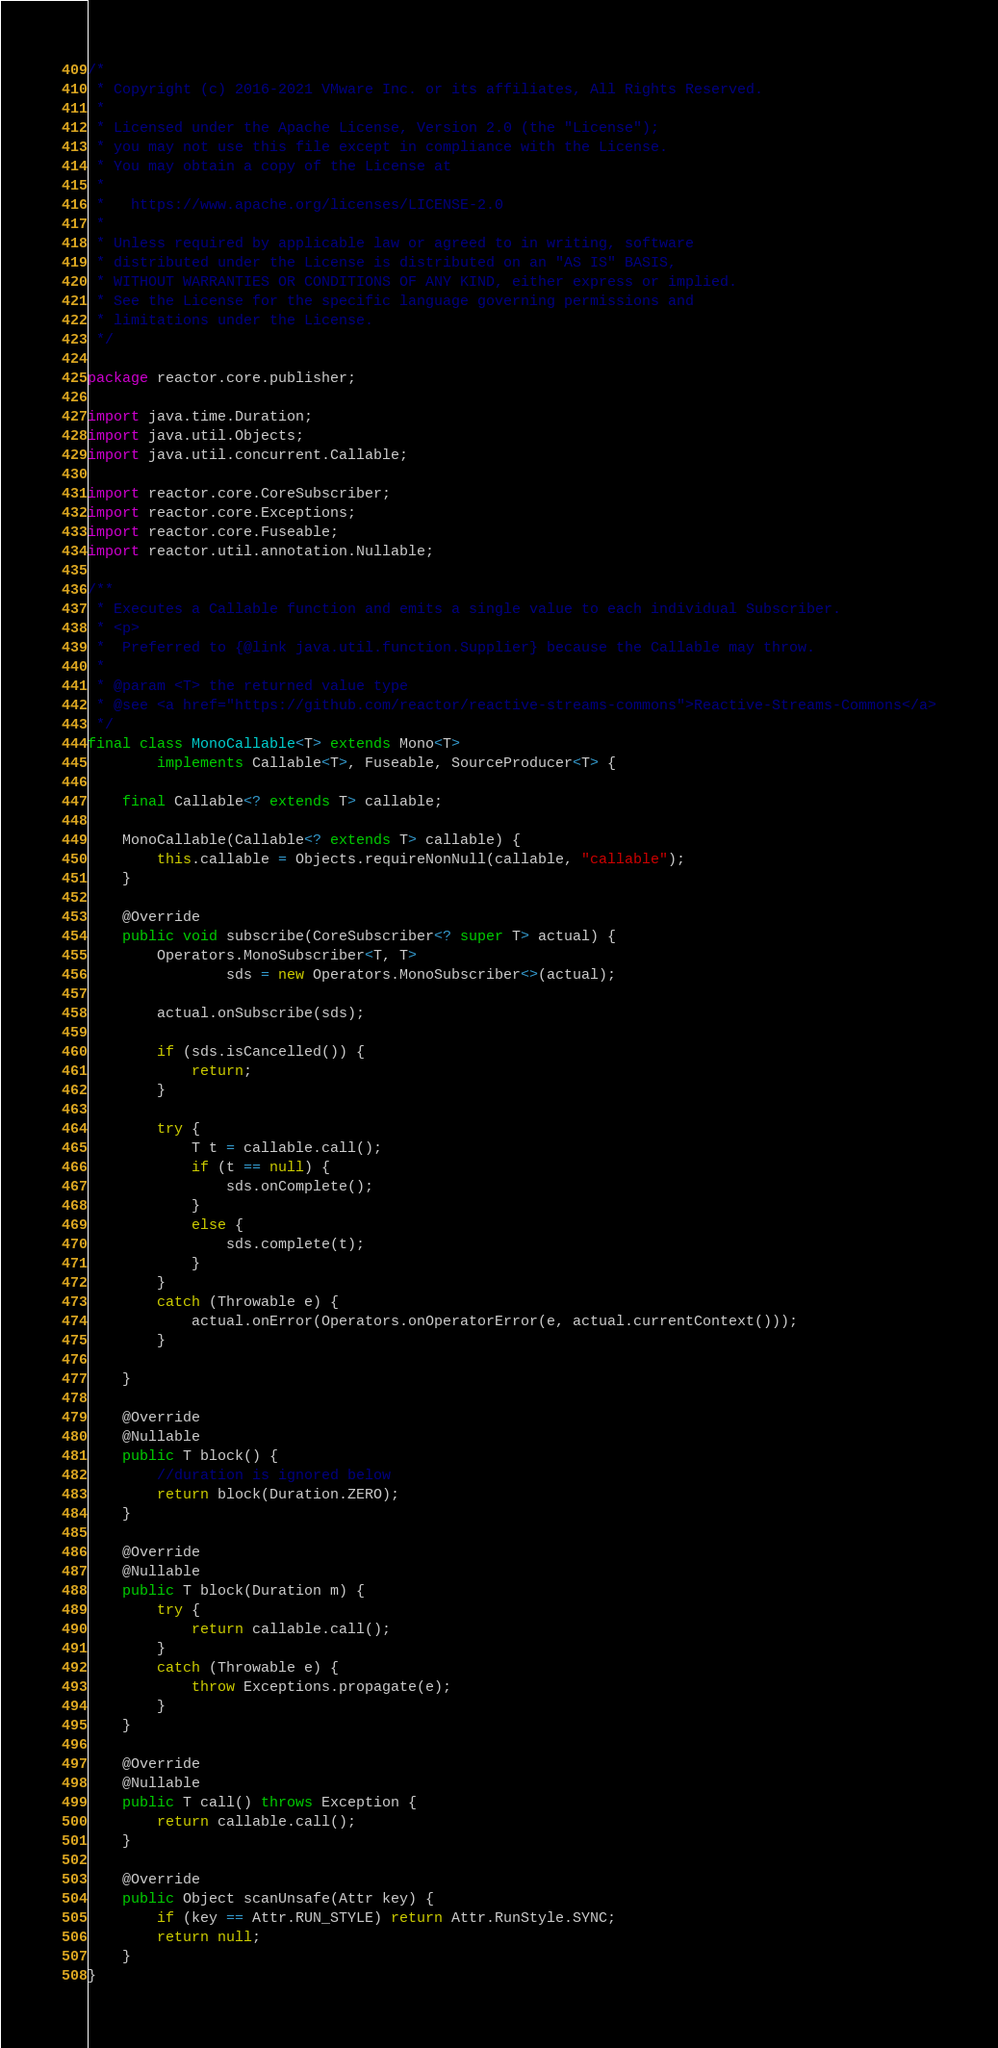Convert code to text. <code><loc_0><loc_0><loc_500><loc_500><_Java_>/*
 * Copyright (c) 2016-2021 VMware Inc. or its affiliates, All Rights Reserved.
 *
 * Licensed under the Apache License, Version 2.0 (the "License");
 * you may not use this file except in compliance with the License.
 * You may obtain a copy of the License at
 *
 *   https://www.apache.org/licenses/LICENSE-2.0
 *
 * Unless required by applicable law or agreed to in writing, software
 * distributed under the License is distributed on an "AS IS" BASIS,
 * WITHOUT WARRANTIES OR CONDITIONS OF ANY KIND, either express or implied.
 * See the License for the specific language governing permissions and
 * limitations under the License.
 */

package reactor.core.publisher;

import java.time.Duration;
import java.util.Objects;
import java.util.concurrent.Callable;

import reactor.core.CoreSubscriber;
import reactor.core.Exceptions;
import reactor.core.Fuseable;
import reactor.util.annotation.Nullable;

/**
 * Executes a Callable function and emits a single value to each individual Subscriber.
 * <p>
 *  Preferred to {@link java.util.function.Supplier} because the Callable may throw.
 *
 * @param <T> the returned value type
 * @see <a href="https://github.com/reactor/reactive-streams-commons">Reactive-Streams-Commons</a>
 */
final class MonoCallable<T> extends Mono<T>
		implements Callable<T>, Fuseable, SourceProducer<T> {

	final Callable<? extends T> callable;

	MonoCallable(Callable<? extends T> callable) {
		this.callable = Objects.requireNonNull(callable, "callable");
	}

	@Override
	public void subscribe(CoreSubscriber<? super T> actual) {
		Operators.MonoSubscriber<T, T>
				sds = new Operators.MonoSubscriber<>(actual);

		actual.onSubscribe(sds);

		if (sds.isCancelled()) {
			return;
		}

		try {
			T t = callable.call();
			if (t == null) {
				sds.onComplete();
			}
			else {
				sds.complete(t);
			}
		}
		catch (Throwable e) {
			actual.onError(Operators.onOperatorError(e, actual.currentContext()));
		}

	}

	@Override
	@Nullable
	public T block() {
		//duration is ignored below
		return block(Duration.ZERO);
	}

	@Override
	@Nullable
	public T block(Duration m) {
		try {
			return callable.call();
		}
		catch (Throwable e) {
			throw Exceptions.propagate(e);
		}
	}

	@Override
	@Nullable
	public T call() throws Exception {
		return callable.call();
	}

	@Override
	public Object scanUnsafe(Attr key) {
		if (key == Attr.RUN_STYLE) return Attr.RunStyle.SYNC;
		return null;
	}
}
</code> 